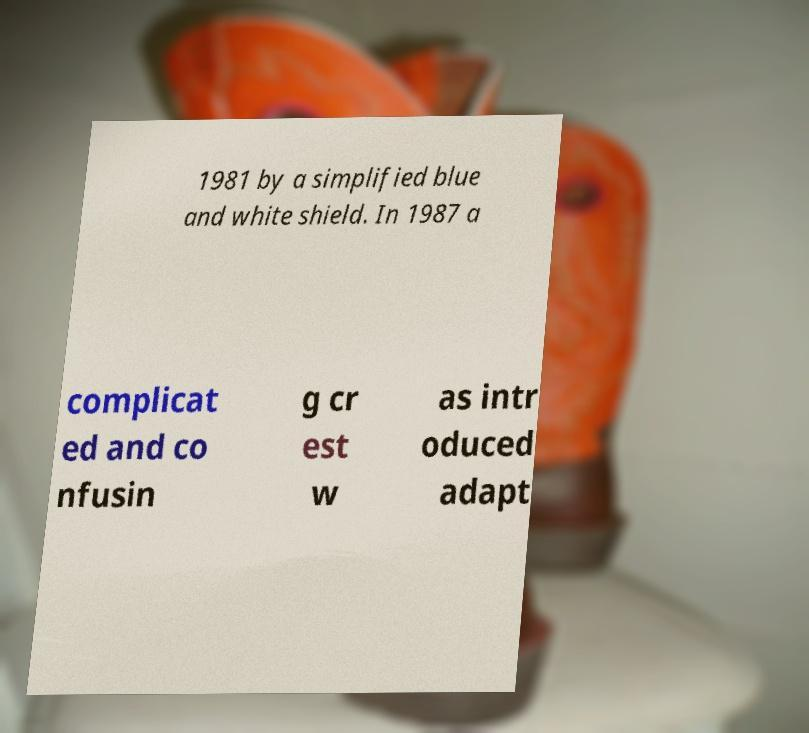For documentation purposes, I need the text within this image transcribed. Could you provide that? 1981 by a simplified blue and white shield. In 1987 a complicat ed and co nfusin g cr est w as intr oduced adapt 